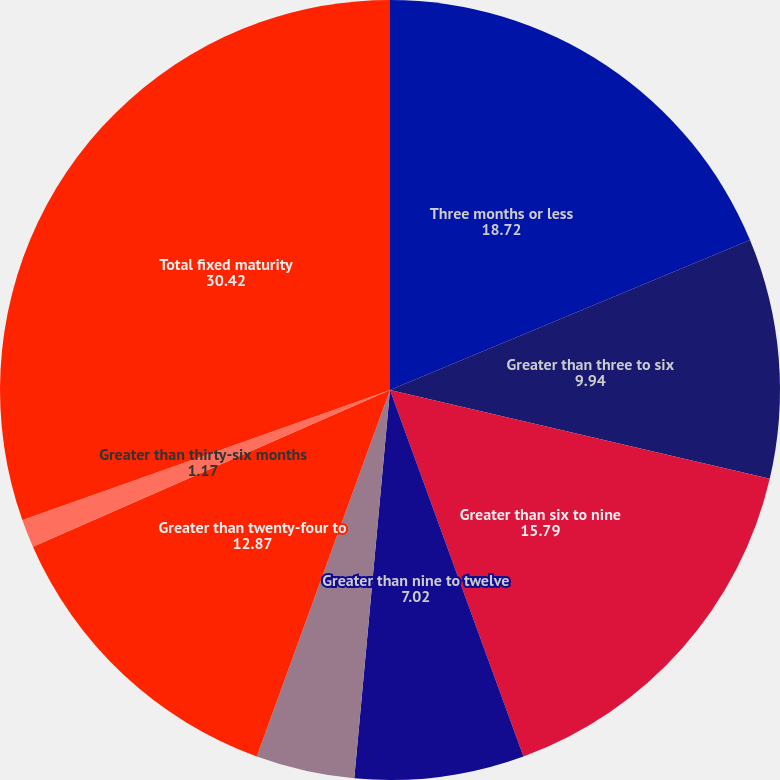<chart> <loc_0><loc_0><loc_500><loc_500><pie_chart><fcel>Three months or less<fcel>Greater than three to six<fcel>Greater than six to nine<fcel>Greater than nine to twelve<fcel>Greater than twelve to<fcel>Greater than twenty-four to<fcel>Greater than thirty-six months<fcel>Total fixed maturity<nl><fcel>18.72%<fcel>9.94%<fcel>15.79%<fcel>7.02%<fcel>4.09%<fcel>12.87%<fcel>1.17%<fcel>30.42%<nl></chart> 